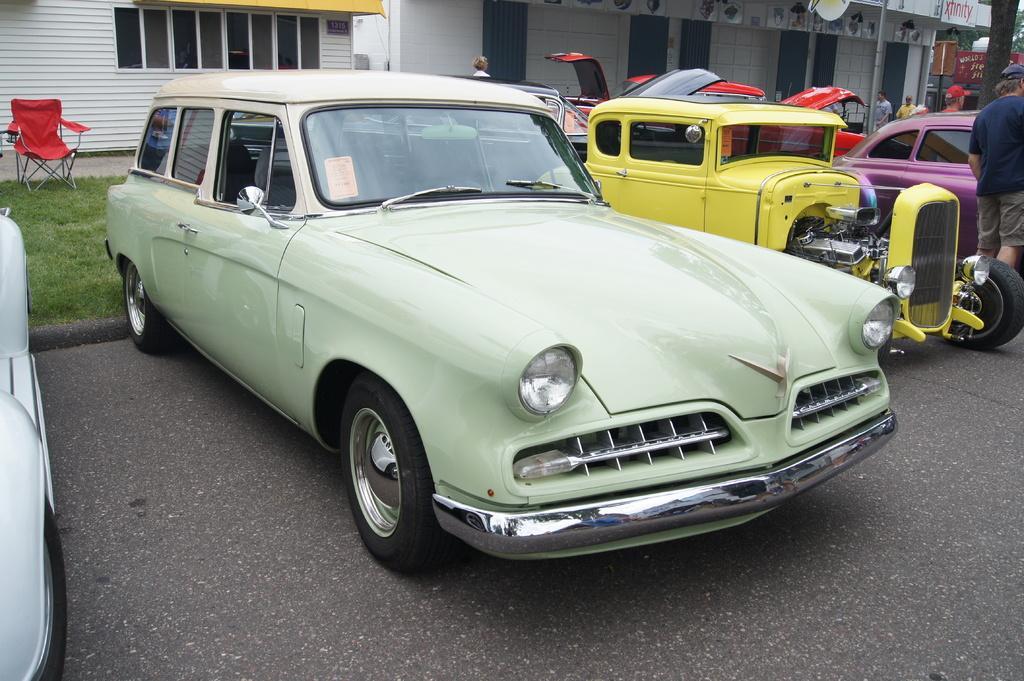Can you describe this image briefly? In this picture we can see the vehicles. At the top of the image we can see the buildings, windows, door, pole, text on the wall, tree. On the left side of the image we can see the grass and a chair. In the background of the image we can see some people are standing. At the bottom of the image we can see the road. 